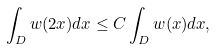Convert formula to latex. <formula><loc_0><loc_0><loc_500><loc_500>\int _ { D } w ( 2 x ) d x \leq C \int _ { D } w ( x ) d x ,</formula> 